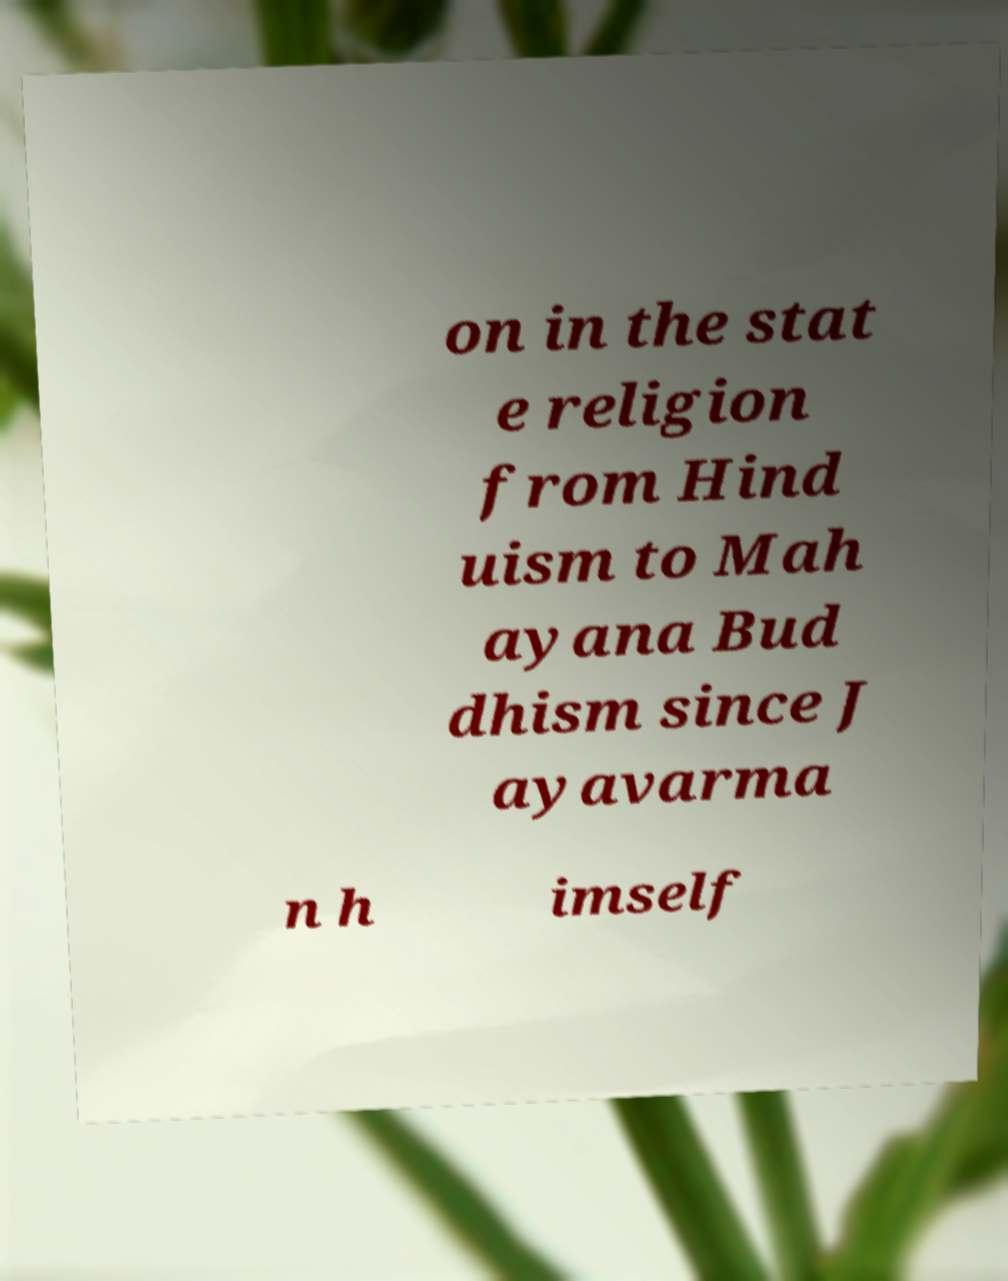I need the written content from this picture converted into text. Can you do that? on in the stat e religion from Hind uism to Mah ayana Bud dhism since J ayavarma n h imself 